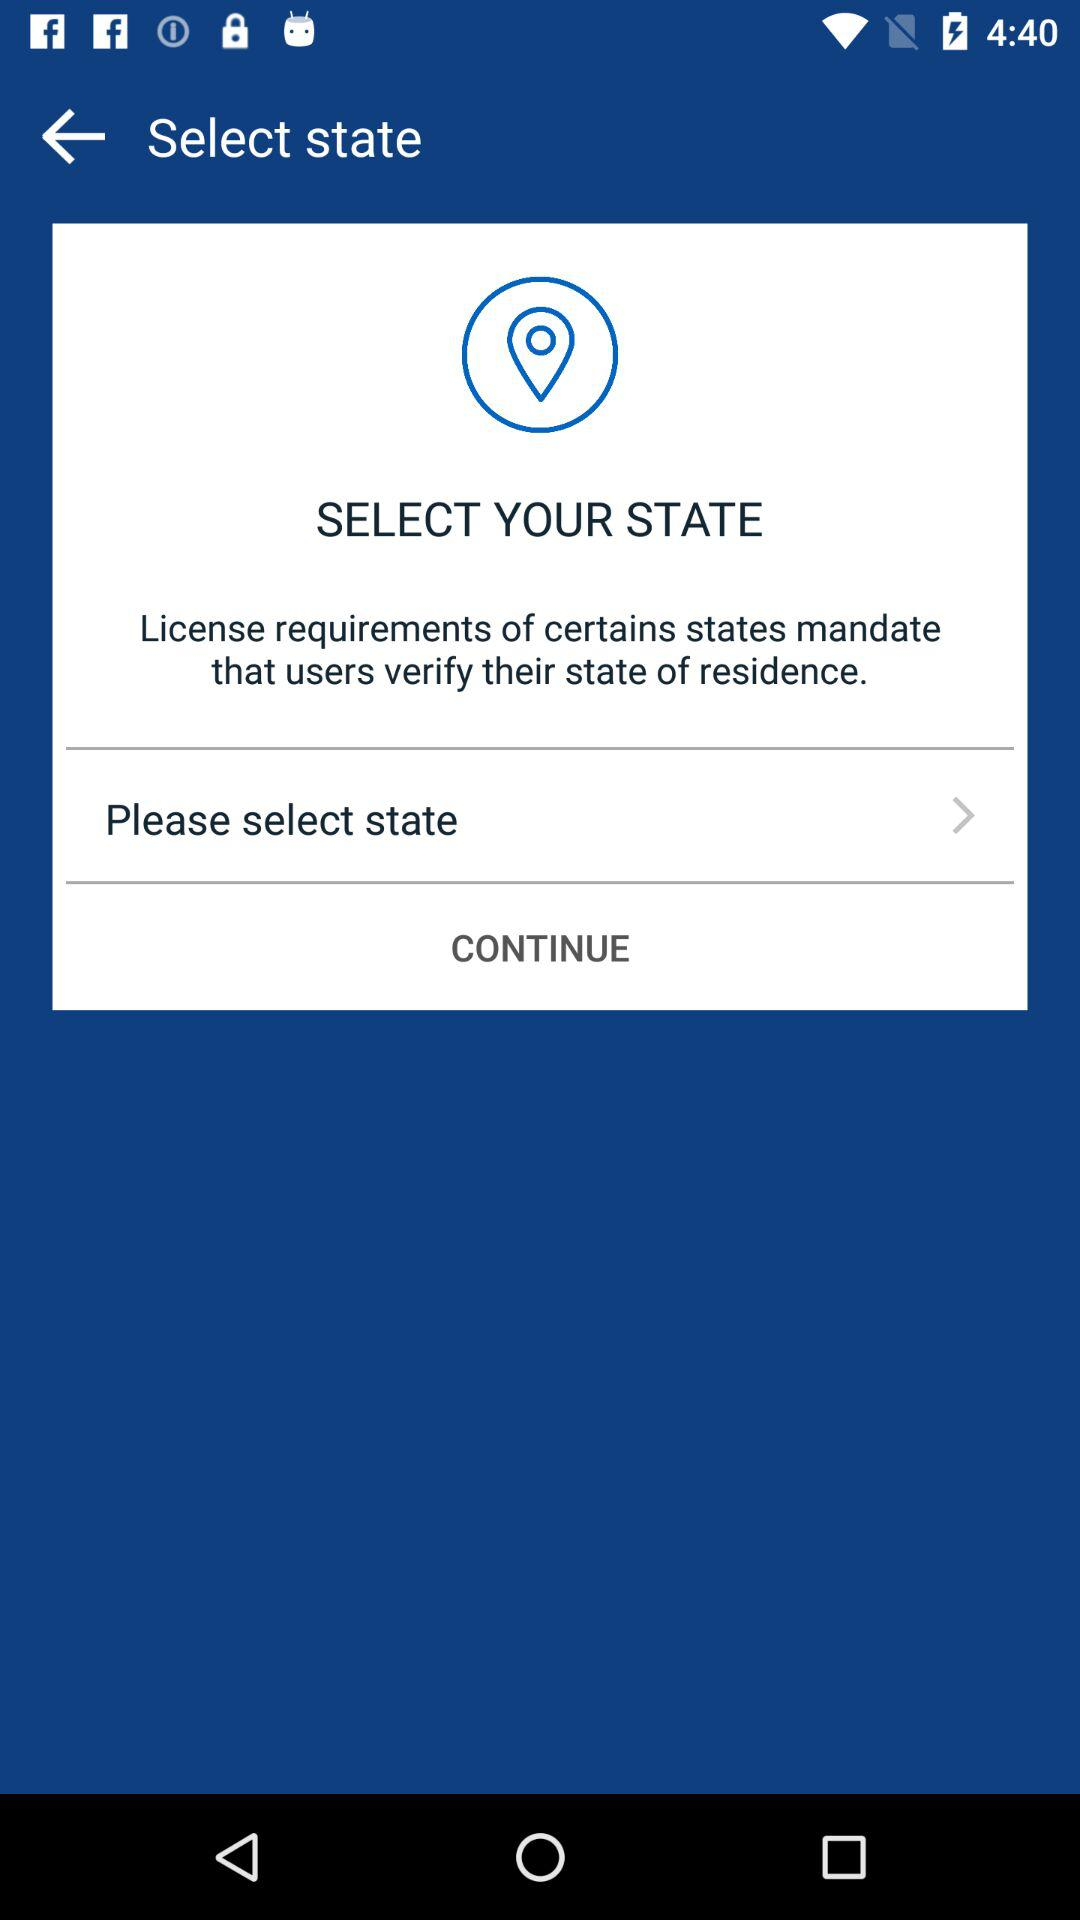Which option is selected between sign up and login?
When the provided information is insufficient, respond with <no answer>. <no answer> 